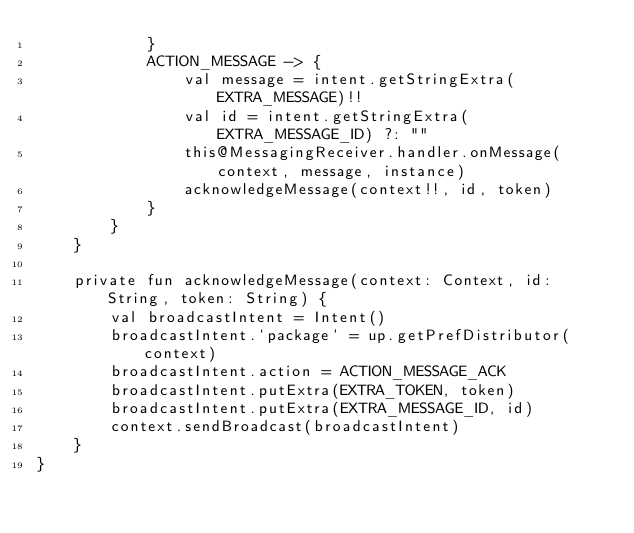<code> <loc_0><loc_0><loc_500><loc_500><_Kotlin_>            }
            ACTION_MESSAGE -> {
                val message = intent.getStringExtra(EXTRA_MESSAGE)!!
                val id = intent.getStringExtra(EXTRA_MESSAGE_ID) ?: ""
                this@MessagingReceiver.handler.onMessage(context, message, instance)
                acknowledgeMessage(context!!, id, token)
            }
        }
    }

    private fun acknowledgeMessage(context: Context, id: String, token: String) {
        val broadcastIntent = Intent()
        broadcastIntent.`package` = up.getPrefDistributor(context)
        broadcastIntent.action = ACTION_MESSAGE_ACK
        broadcastIntent.putExtra(EXTRA_TOKEN, token)
        broadcastIntent.putExtra(EXTRA_MESSAGE_ID, id)
        context.sendBroadcast(broadcastIntent)
    }
}
</code> 